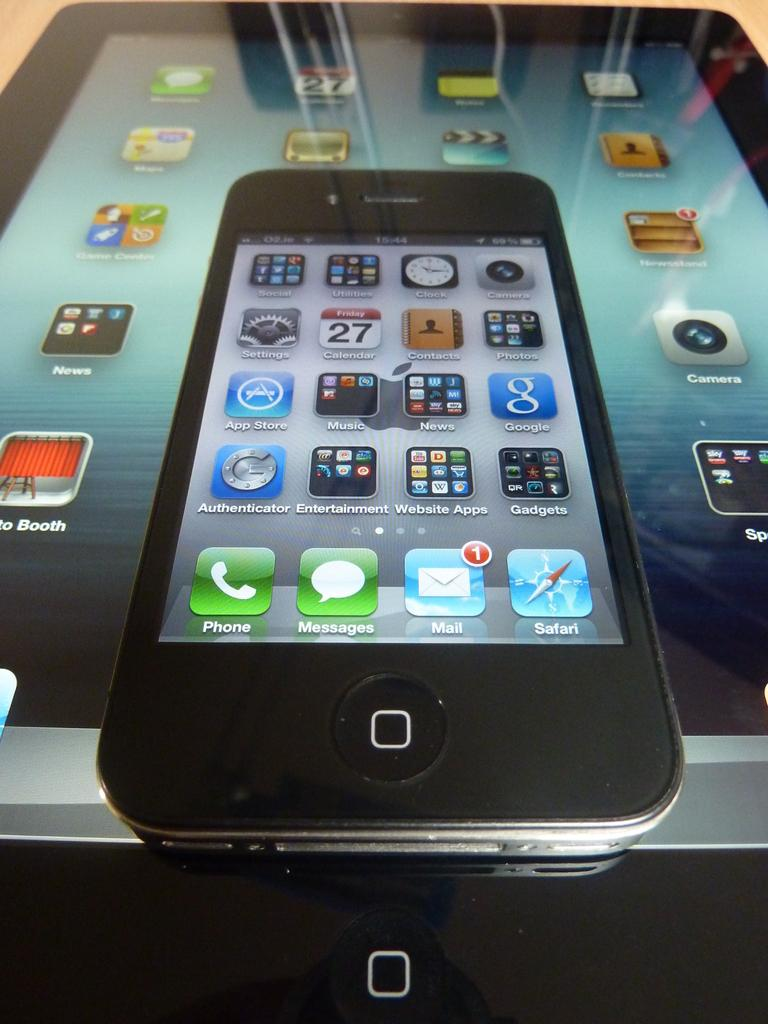<image>
Render a clear and concise summary of the photo. An iphone lays on top of an ipad, both with screens lit up and application icons visible. 